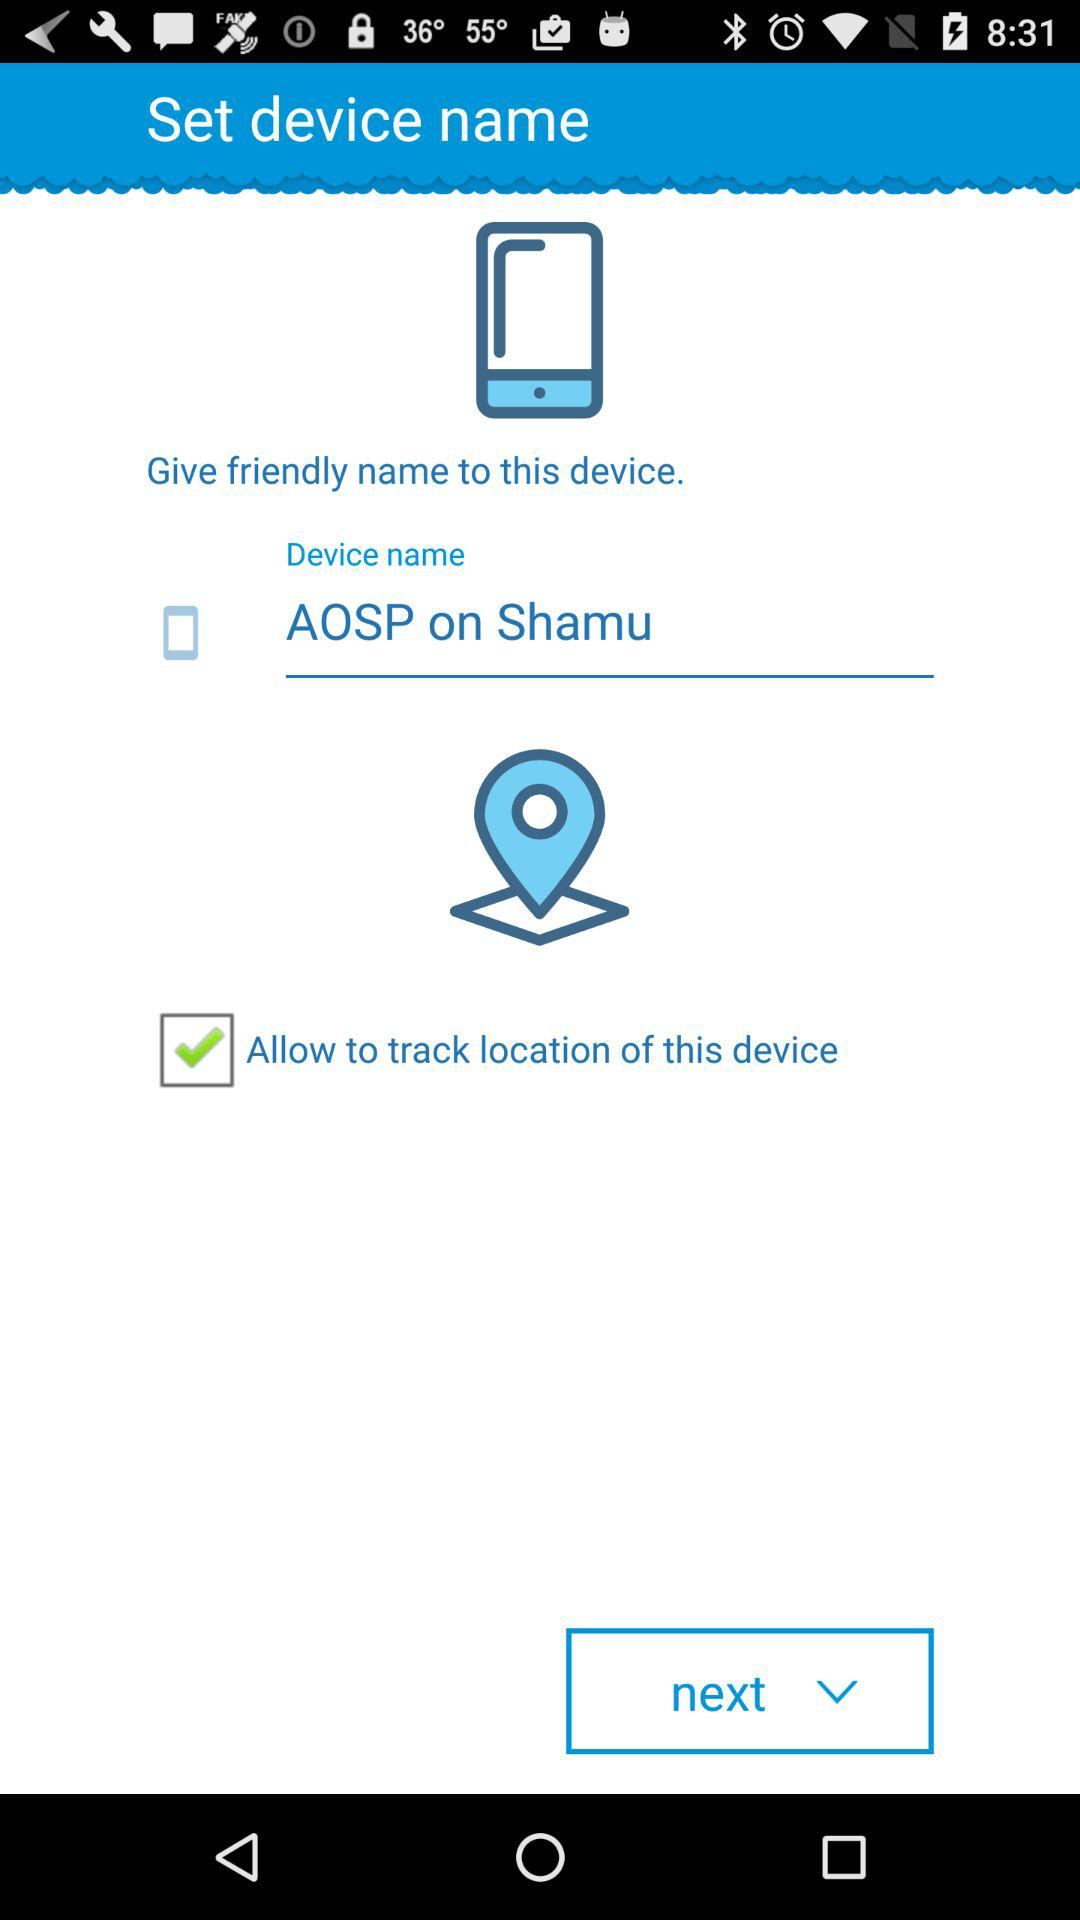What is the status of "Allow to track location"? The status is "on". 